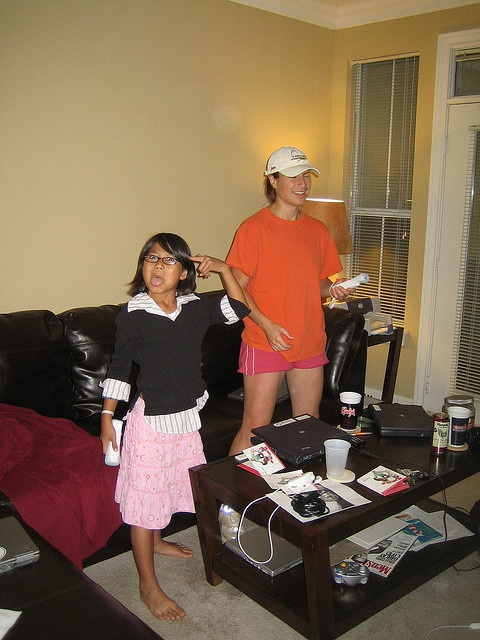Describe the objects in this image and their specific colors. I can see people in olive, black, pink, and lightpink tones, people in olive, red, salmon, brown, and black tones, couch in olive, black, maroon, gray, and darkgray tones, couch in olive, black, and gray tones, and laptop in olive, black, gray, and darkgray tones in this image. 